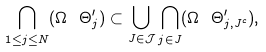Convert formula to latex. <formula><loc_0><loc_0><loc_500><loc_500>\bigcap _ { 1 \leq j \leq N } ( \Omega \ \Theta _ { j } ^ { \prime } ) \subset \bigcup _ { J \in { \mathcal { J } } } \bigcap _ { j \in J } ( \Omega \ \Theta _ { j , J ^ { c } } ^ { \prime } ) ,</formula> 